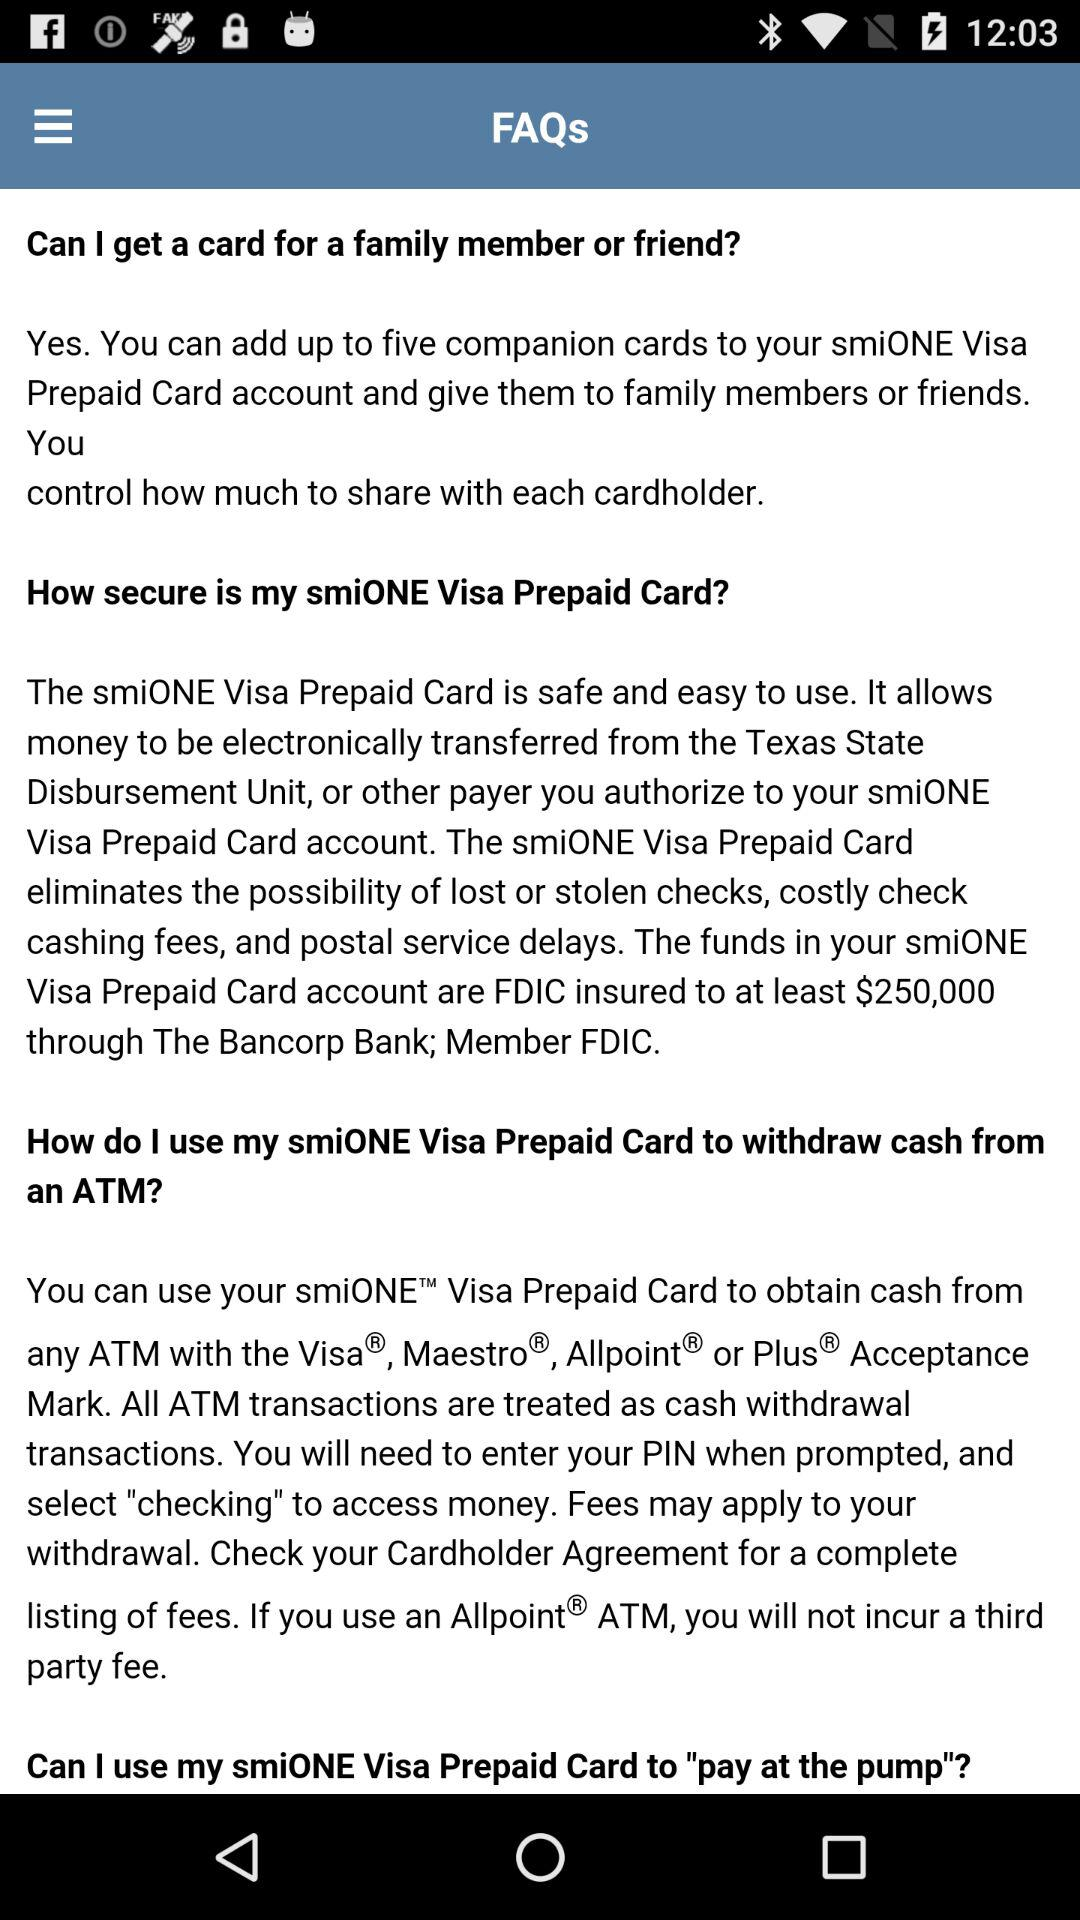How much money is FDIC insured on my account?
Answer the question using a single word or phrase. $250,000 